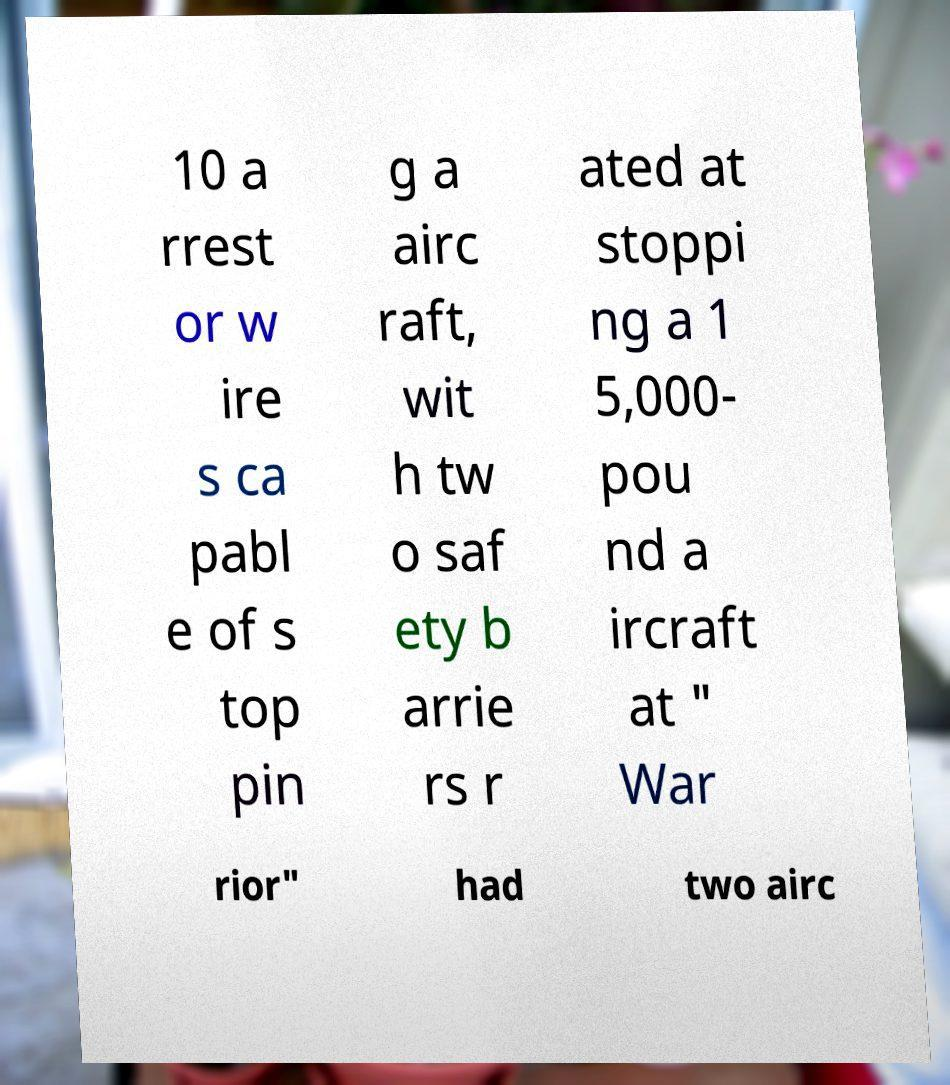I need the written content from this picture converted into text. Can you do that? 10 a rrest or w ire s ca pabl e of s top pin g a airc raft, wit h tw o saf ety b arrie rs r ated at stoppi ng a 1 5,000- pou nd a ircraft at " War rior" had two airc 